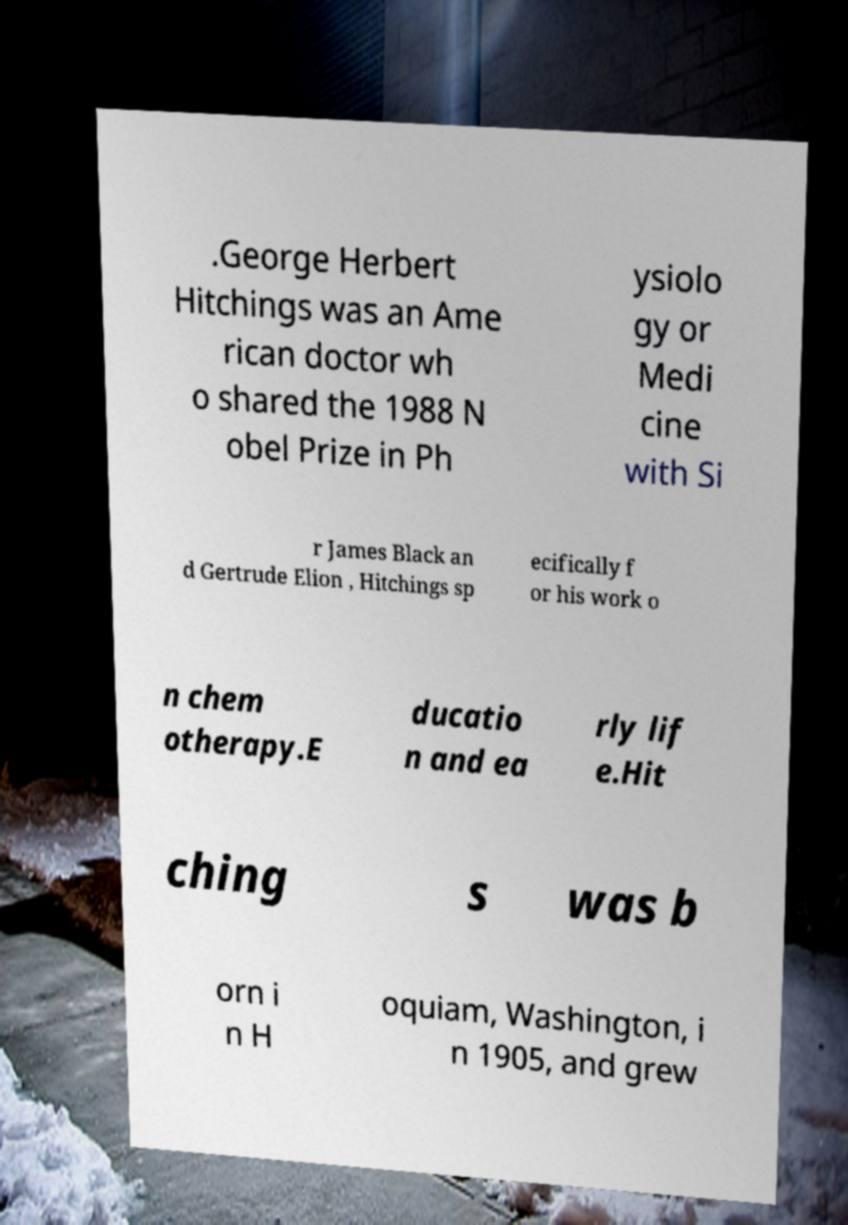Could you extract and type out the text from this image? .George Herbert Hitchings was an Ame rican doctor wh o shared the 1988 N obel Prize in Ph ysiolo gy or Medi cine with Si r James Black an d Gertrude Elion , Hitchings sp ecifically f or his work o n chem otherapy.E ducatio n and ea rly lif e.Hit ching s was b orn i n H oquiam, Washington, i n 1905, and grew 